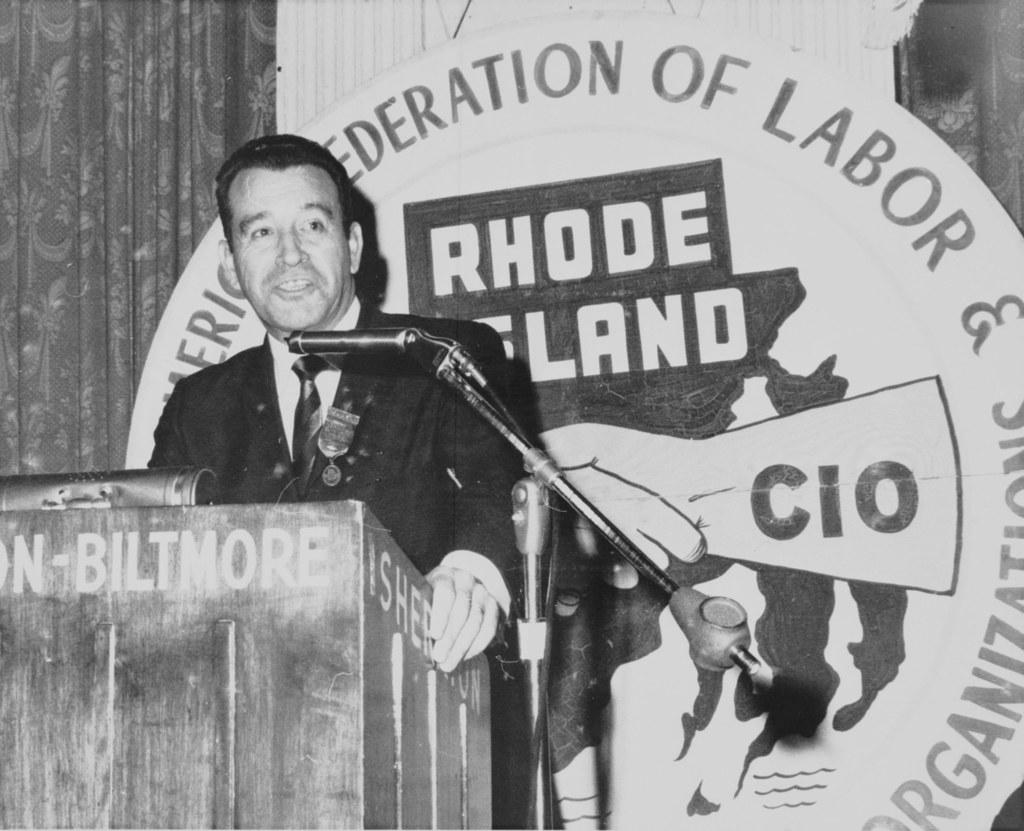What is the person in the image doing? The person is standing in front of the podium. What is the person likely to use to amplify their voice? There is a microphone in front of the person. What can be seen in the background of the image? There is a text and a curtain in the background. What type of calculator is being used during the operation in the image? There is no calculator or operation present in the image. 